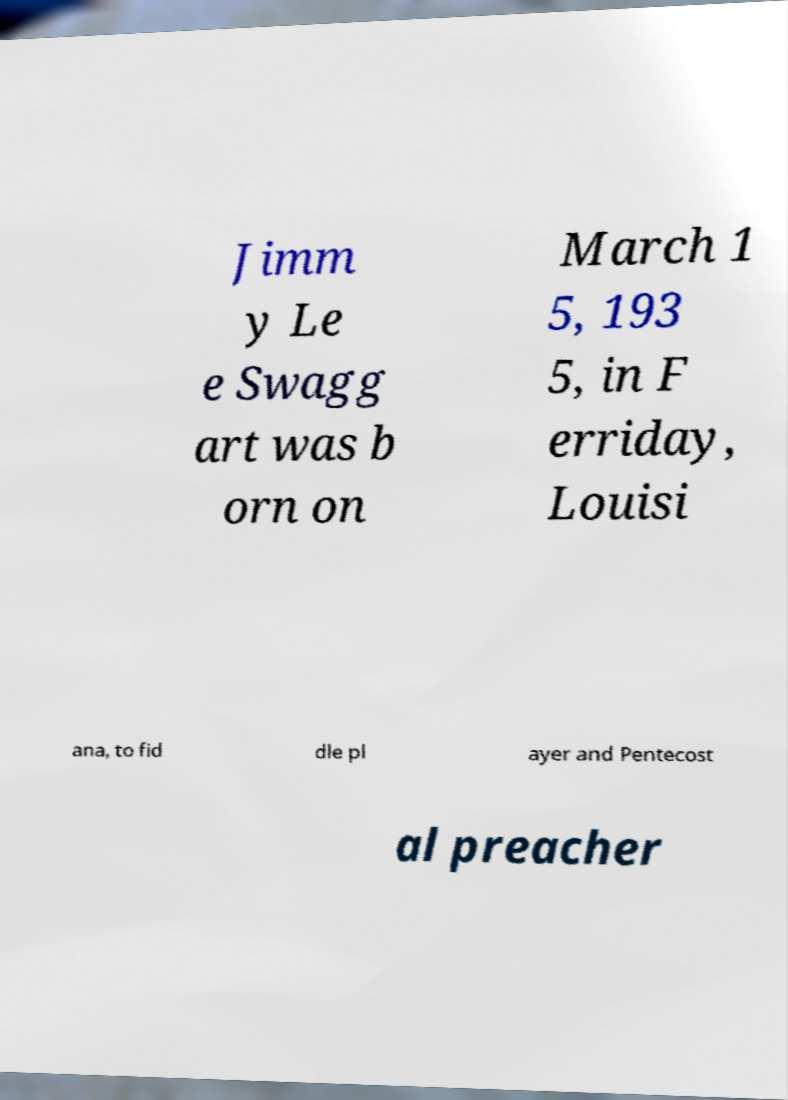Please read and relay the text visible in this image. What does it say? Jimm y Le e Swagg art was b orn on March 1 5, 193 5, in F erriday, Louisi ana, to fid dle pl ayer and Pentecost al preacher 